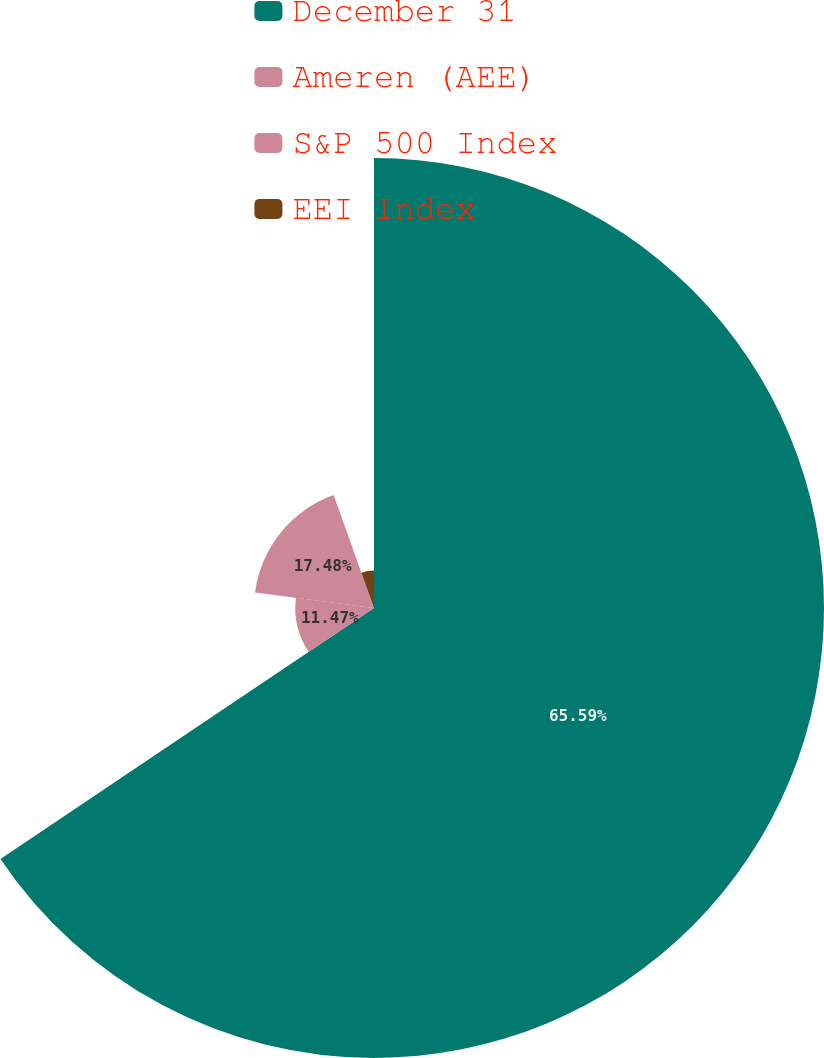<chart> <loc_0><loc_0><loc_500><loc_500><pie_chart><fcel>December 31<fcel>Ameren (AEE)<fcel>S&P 500 Index<fcel>EEI Index<nl><fcel>65.58%<fcel>11.47%<fcel>17.48%<fcel>5.46%<nl></chart> 